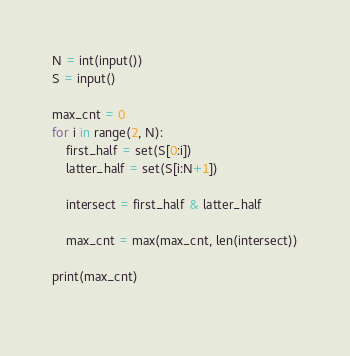<code> <loc_0><loc_0><loc_500><loc_500><_Python_>N = int(input())
S = input()

max_cnt = 0
for i in range(2, N):
    first_half = set(S[0:i])
    latter_half = set(S[i:N+1])

    intersect = first_half & latter_half

    max_cnt = max(max_cnt, len(intersect))

print(max_cnt)
    


</code> 